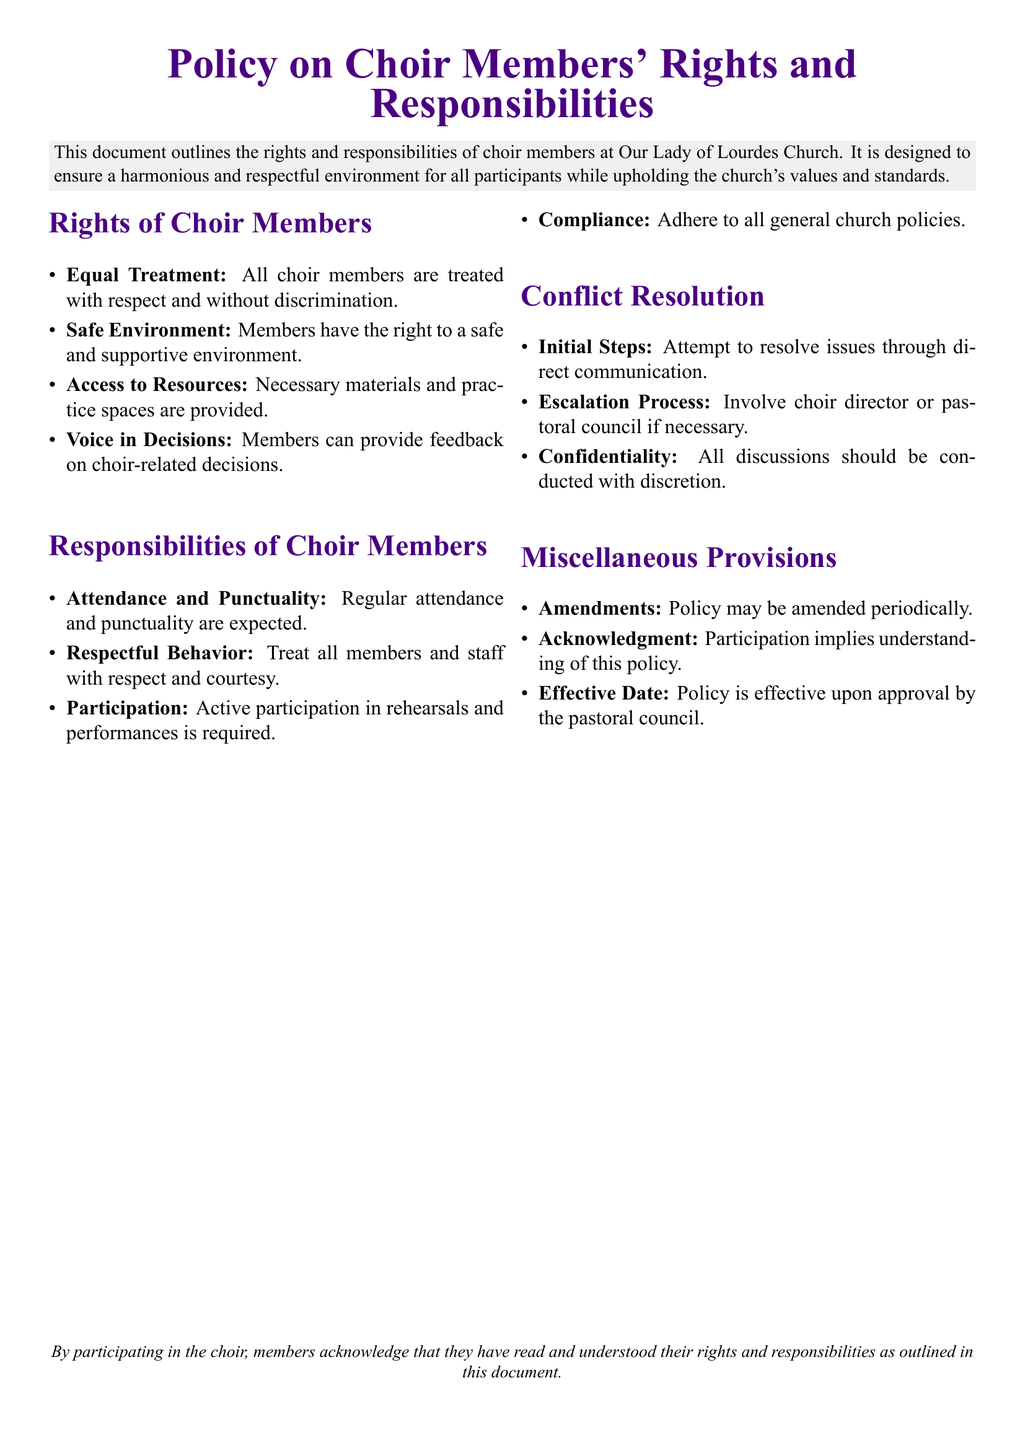What is the main purpose of the document? The document outlines the rights and responsibilities of choir members to ensure a harmonious and respectful environment.
Answer: To ensure a harmonious environment What right do choir members have regarding decisions? Members can provide feedback on choir-related decisions as part of their rights.
Answer: Voice in Decisions What is expected regarding attendance? The document states that regular attendance and punctuality are expected from choir members.
Answer: Regular attendance What should members do when resolving conflicts? Members are advised to attempt resolving issues through direct communication first.
Answer: Direct communication What color is used for the section titles? The document specifies a purple color for the section titles, labeled as churchpurple.
Answer: Purple How often may the policy be amended? The document notes that the policy may be amended periodically, though it does not specify a frequency.
Answer: Periodically What is the effective date condition mentioned in the document? The policy becomes effective upon approval by the pastoral council.
Answer: Upon approval What is required of choir members during rehearsals? Active participation in rehearsals is required from choir members as stated in their responsibilities.
Answer: Active participation What action should be taken if initial conflict resolution fails? If issues are not resolved, members should involve the choir director or pastoral council.
Answer: Involve choir director 